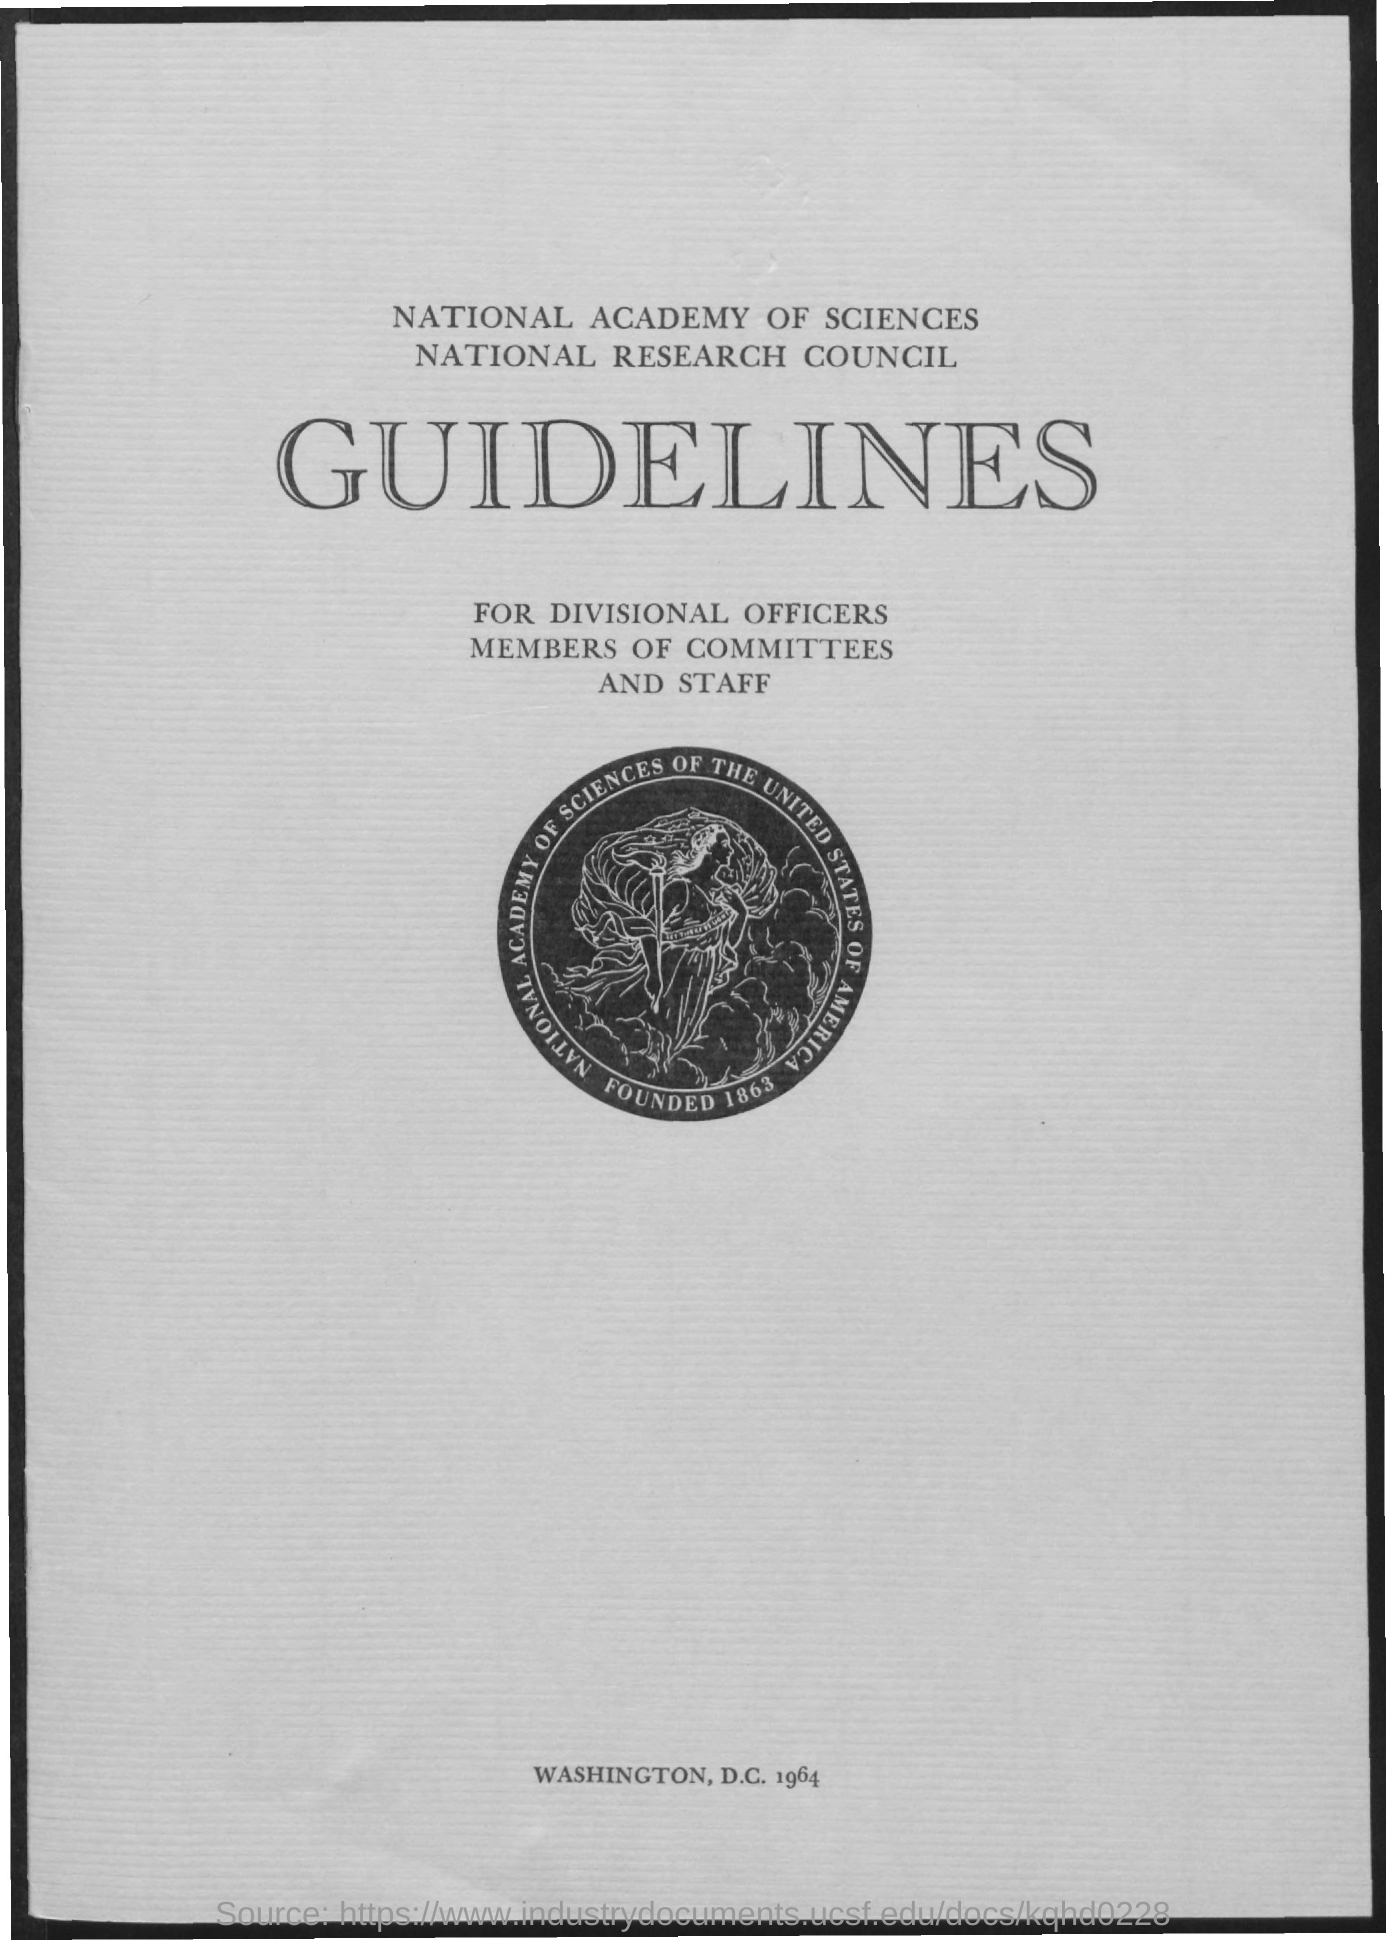Indicate a few pertinent items in this graphic. The year that is situated at the bottom of the document is 1964. The year depicted in the image is 1863. 